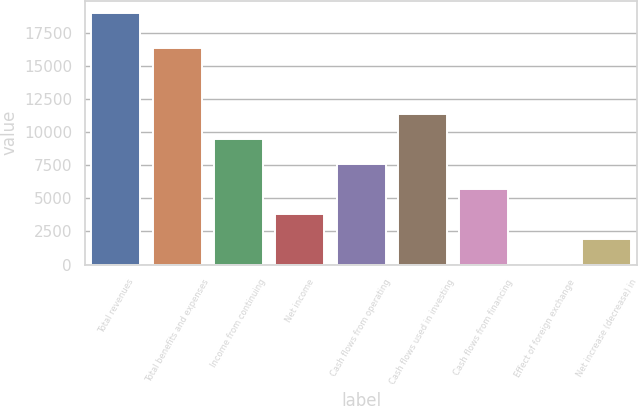Convert chart. <chart><loc_0><loc_0><loc_500><loc_500><bar_chart><fcel>Total revenues<fcel>Total benefits and expenses<fcel>Income from continuing<fcel>Net income<fcel>Cash flows from operating<fcel>Cash flows used in investing<fcel>Cash flows from financing<fcel>Effect of foreign exchange<fcel>Net increase (decrease) in<nl><fcel>18955<fcel>16363<fcel>9493.5<fcel>3816.6<fcel>7601.2<fcel>11385.8<fcel>5708.9<fcel>32<fcel>1924.3<nl></chart> 